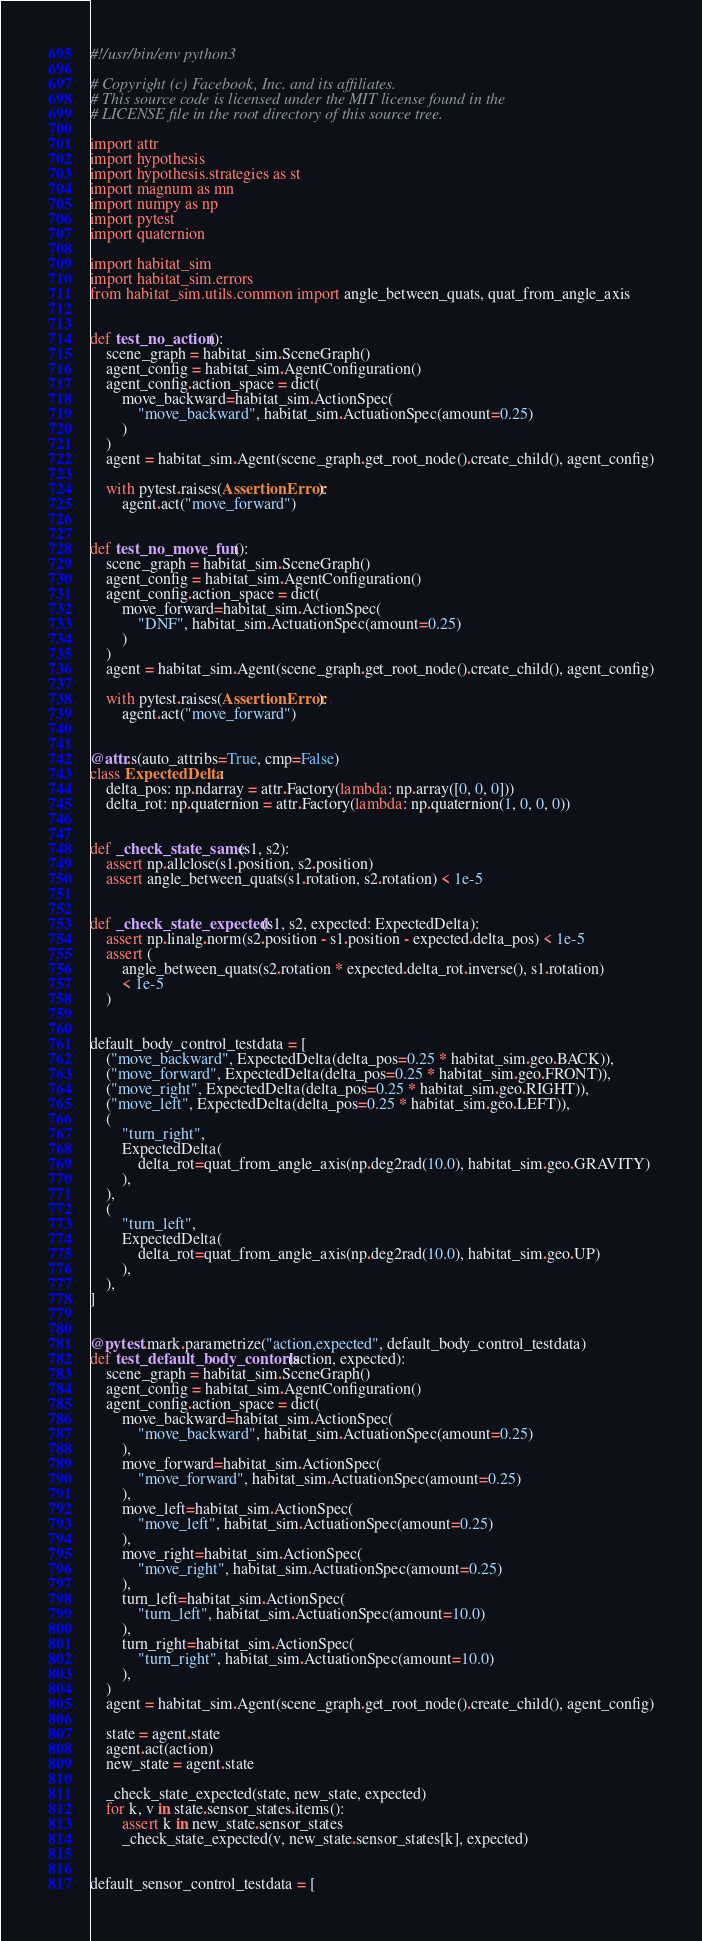<code> <loc_0><loc_0><loc_500><loc_500><_Python_>#!/usr/bin/env python3

# Copyright (c) Facebook, Inc. and its affiliates.
# This source code is licensed under the MIT license found in the
# LICENSE file in the root directory of this source tree.

import attr
import hypothesis
import hypothesis.strategies as st
import magnum as mn
import numpy as np
import pytest
import quaternion

import habitat_sim
import habitat_sim.errors
from habitat_sim.utils.common import angle_between_quats, quat_from_angle_axis


def test_no_action():
    scene_graph = habitat_sim.SceneGraph()
    agent_config = habitat_sim.AgentConfiguration()
    agent_config.action_space = dict(
        move_backward=habitat_sim.ActionSpec(
            "move_backward", habitat_sim.ActuationSpec(amount=0.25)
        )
    )
    agent = habitat_sim.Agent(scene_graph.get_root_node().create_child(), agent_config)

    with pytest.raises(AssertionError):
        agent.act("move_forward")


def test_no_move_fun():
    scene_graph = habitat_sim.SceneGraph()
    agent_config = habitat_sim.AgentConfiguration()
    agent_config.action_space = dict(
        move_forward=habitat_sim.ActionSpec(
            "DNF", habitat_sim.ActuationSpec(amount=0.25)
        )
    )
    agent = habitat_sim.Agent(scene_graph.get_root_node().create_child(), agent_config)

    with pytest.raises(AssertionError):
        agent.act("move_forward")


@attr.s(auto_attribs=True, cmp=False)
class ExpectedDelta:
    delta_pos: np.ndarray = attr.Factory(lambda: np.array([0, 0, 0]))
    delta_rot: np.quaternion = attr.Factory(lambda: np.quaternion(1, 0, 0, 0))


def _check_state_same(s1, s2):
    assert np.allclose(s1.position, s2.position)
    assert angle_between_quats(s1.rotation, s2.rotation) < 1e-5


def _check_state_expected(s1, s2, expected: ExpectedDelta):
    assert np.linalg.norm(s2.position - s1.position - expected.delta_pos) < 1e-5
    assert (
        angle_between_quats(s2.rotation * expected.delta_rot.inverse(), s1.rotation)
        < 1e-5
    )


default_body_control_testdata = [
    ("move_backward", ExpectedDelta(delta_pos=0.25 * habitat_sim.geo.BACK)),
    ("move_forward", ExpectedDelta(delta_pos=0.25 * habitat_sim.geo.FRONT)),
    ("move_right", ExpectedDelta(delta_pos=0.25 * habitat_sim.geo.RIGHT)),
    ("move_left", ExpectedDelta(delta_pos=0.25 * habitat_sim.geo.LEFT)),
    (
        "turn_right",
        ExpectedDelta(
            delta_rot=quat_from_angle_axis(np.deg2rad(10.0), habitat_sim.geo.GRAVITY)
        ),
    ),
    (
        "turn_left",
        ExpectedDelta(
            delta_rot=quat_from_angle_axis(np.deg2rad(10.0), habitat_sim.geo.UP)
        ),
    ),
]


@pytest.mark.parametrize("action,expected", default_body_control_testdata)
def test_default_body_contorls(action, expected):
    scene_graph = habitat_sim.SceneGraph()
    agent_config = habitat_sim.AgentConfiguration()
    agent_config.action_space = dict(
        move_backward=habitat_sim.ActionSpec(
            "move_backward", habitat_sim.ActuationSpec(amount=0.25)
        ),
        move_forward=habitat_sim.ActionSpec(
            "move_forward", habitat_sim.ActuationSpec(amount=0.25)
        ),
        move_left=habitat_sim.ActionSpec(
            "move_left", habitat_sim.ActuationSpec(amount=0.25)
        ),
        move_right=habitat_sim.ActionSpec(
            "move_right", habitat_sim.ActuationSpec(amount=0.25)
        ),
        turn_left=habitat_sim.ActionSpec(
            "turn_left", habitat_sim.ActuationSpec(amount=10.0)
        ),
        turn_right=habitat_sim.ActionSpec(
            "turn_right", habitat_sim.ActuationSpec(amount=10.0)
        ),
    )
    agent = habitat_sim.Agent(scene_graph.get_root_node().create_child(), agent_config)

    state = agent.state
    agent.act(action)
    new_state = agent.state

    _check_state_expected(state, new_state, expected)
    for k, v in state.sensor_states.items():
        assert k in new_state.sensor_states
        _check_state_expected(v, new_state.sensor_states[k], expected)


default_sensor_control_testdata = [</code> 